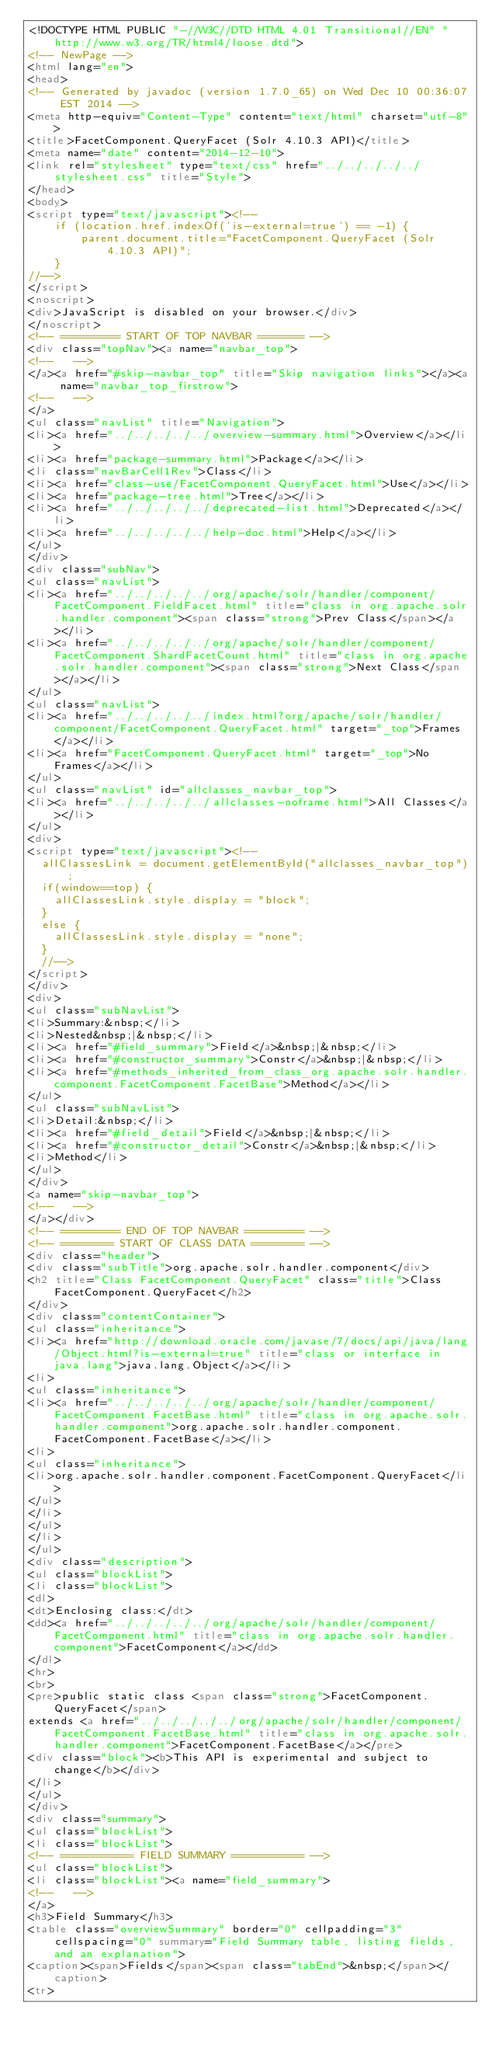<code> <loc_0><loc_0><loc_500><loc_500><_HTML_><!DOCTYPE HTML PUBLIC "-//W3C//DTD HTML 4.01 Transitional//EN" "http://www.w3.org/TR/html4/loose.dtd">
<!-- NewPage -->
<html lang="en">
<head>
<!-- Generated by javadoc (version 1.7.0_65) on Wed Dec 10 00:36:07 EST 2014 -->
<meta http-equiv="Content-Type" content="text/html" charset="utf-8">
<title>FacetComponent.QueryFacet (Solr 4.10.3 API)</title>
<meta name="date" content="2014-12-10">
<link rel="stylesheet" type="text/css" href="../../../../../stylesheet.css" title="Style">
</head>
<body>
<script type="text/javascript"><!--
    if (location.href.indexOf('is-external=true') == -1) {
        parent.document.title="FacetComponent.QueryFacet (Solr 4.10.3 API)";
    }
//-->
</script>
<noscript>
<div>JavaScript is disabled on your browser.</div>
</noscript>
<!-- ========= START OF TOP NAVBAR ======= -->
<div class="topNav"><a name="navbar_top">
<!--   -->
</a><a href="#skip-navbar_top" title="Skip navigation links"></a><a name="navbar_top_firstrow">
<!--   -->
</a>
<ul class="navList" title="Navigation">
<li><a href="../../../../../overview-summary.html">Overview</a></li>
<li><a href="package-summary.html">Package</a></li>
<li class="navBarCell1Rev">Class</li>
<li><a href="class-use/FacetComponent.QueryFacet.html">Use</a></li>
<li><a href="package-tree.html">Tree</a></li>
<li><a href="../../../../../deprecated-list.html">Deprecated</a></li>
<li><a href="../../../../../help-doc.html">Help</a></li>
</ul>
</div>
<div class="subNav">
<ul class="navList">
<li><a href="../../../../../org/apache/solr/handler/component/FacetComponent.FieldFacet.html" title="class in org.apache.solr.handler.component"><span class="strong">Prev Class</span></a></li>
<li><a href="../../../../../org/apache/solr/handler/component/FacetComponent.ShardFacetCount.html" title="class in org.apache.solr.handler.component"><span class="strong">Next Class</span></a></li>
</ul>
<ul class="navList">
<li><a href="../../../../../index.html?org/apache/solr/handler/component/FacetComponent.QueryFacet.html" target="_top">Frames</a></li>
<li><a href="FacetComponent.QueryFacet.html" target="_top">No Frames</a></li>
</ul>
<ul class="navList" id="allclasses_navbar_top">
<li><a href="../../../../../allclasses-noframe.html">All Classes</a></li>
</ul>
<div>
<script type="text/javascript"><!--
  allClassesLink = document.getElementById("allclasses_navbar_top");
  if(window==top) {
    allClassesLink.style.display = "block";
  }
  else {
    allClassesLink.style.display = "none";
  }
  //-->
</script>
</div>
<div>
<ul class="subNavList">
<li>Summary:&nbsp;</li>
<li>Nested&nbsp;|&nbsp;</li>
<li><a href="#field_summary">Field</a>&nbsp;|&nbsp;</li>
<li><a href="#constructor_summary">Constr</a>&nbsp;|&nbsp;</li>
<li><a href="#methods_inherited_from_class_org.apache.solr.handler.component.FacetComponent.FacetBase">Method</a></li>
</ul>
<ul class="subNavList">
<li>Detail:&nbsp;</li>
<li><a href="#field_detail">Field</a>&nbsp;|&nbsp;</li>
<li><a href="#constructor_detail">Constr</a>&nbsp;|&nbsp;</li>
<li>Method</li>
</ul>
</div>
<a name="skip-navbar_top">
<!--   -->
</a></div>
<!-- ========= END OF TOP NAVBAR ========= -->
<!-- ======== START OF CLASS DATA ======== -->
<div class="header">
<div class="subTitle">org.apache.solr.handler.component</div>
<h2 title="Class FacetComponent.QueryFacet" class="title">Class FacetComponent.QueryFacet</h2>
</div>
<div class="contentContainer">
<ul class="inheritance">
<li><a href="http://download.oracle.com/javase/7/docs/api/java/lang/Object.html?is-external=true" title="class or interface in java.lang">java.lang.Object</a></li>
<li>
<ul class="inheritance">
<li><a href="../../../../../org/apache/solr/handler/component/FacetComponent.FacetBase.html" title="class in org.apache.solr.handler.component">org.apache.solr.handler.component.FacetComponent.FacetBase</a></li>
<li>
<ul class="inheritance">
<li>org.apache.solr.handler.component.FacetComponent.QueryFacet</li>
</ul>
</li>
</ul>
</li>
</ul>
<div class="description">
<ul class="blockList">
<li class="blockList">
<dl>
<dt>Enclosing class:</dt>
<dd><a href="../../../../../org/apache/solr/handler/component/FacetComponent.html" title="class in org.apache.solr.handler.component">FacetComponent</a></dd>
</dl>
<hr>
<br>
<pre>public static class <span class="strong">FacetComponent.QueryFacet</span>
extends <a href="../../../../../org/apache/solr/handler/component/FacetComponent.FacetBase.html" title="class in org.apache.solr.handler.component">FacetComponent.FacetBase</a></pre>
<div class="block"><b>This API is experimental and subject to change</b></div>
</li>
</ul>
</div>
<div class="summary">
<ul class="blockList">
<li class="blockList">
<!-- =========== FIELD SUMMARY =========== -->
<ul class="blockList">
<li class="blockList"><a name="field_summary">
<!--   -->
</a>
<h3>Field Summary</h3>
<table class="overviewSummary" border="0" cellpadding="3" cellspacing="0" summary="Field Summary table, listing fields, and an explanation">
<caption><span>Fields</span><span class="tabEnd">&nbsp;</span></caption>
<tr></code> 